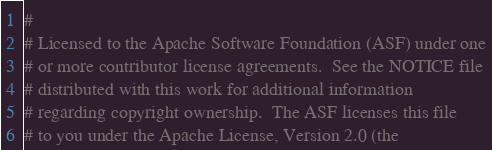Convert code to text. <code><loc_0><loc_0><loc_500><loc_500><_Python_>#
# Licensed to the Apache Software Foundation (ASF) under one
# or more contributor license agreements.  See the NOTICE file
# distributed with this work for additional information
# regarding copyright ownership.  The ASF licenses this file
# to you under the Apache License, Version 2.0 (the</code> 